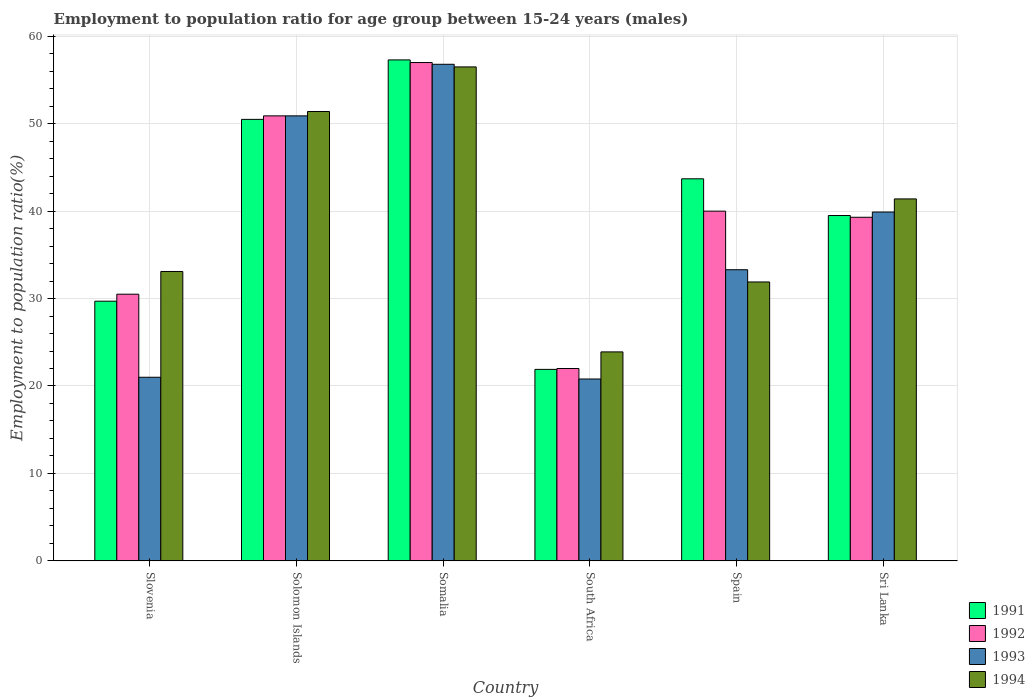How many different coloured bars are there?
Provide a short and direct response. 4. How many bars are there on the 3rd tick from the right?
Your answer should be very brief. 4. What is the employment to population ratio in 1994 in Solomon Islands?
Provide a succinct answer. 51.4. Across all countries, what is the maximum employment to population ratio in 1992?
Offer a very short reply. 57. Across all countries, what is the minimum employment to population ratio in 1993?
Give a very brief answer. 20.8. In which country was the employment to population ratio in 1991 maximum?
Ensure brevity in your answer.  Somalia. In which country was the employment to population ratio in 1991 minimum?
Offer a very short reply. South Africa. What is the total employment to population ratio in 1992 in the graph?
Provide a short and direct response. 239.7. What is the difference between the employment to population ratio in 1994 in Solomon Islands and that in Spain?
Make the answer very short. 19.5. What is the difference between the employment to population ratio in 1994 in Sri Lanka and the employment to population ratio in 1991 in Solomon Islands?
Your answer should be compact. -9.1. What is the average employment to population ratio in 1994 per country?
Make the answer very short. 39.7. What is the difference between the employment to population ratio of/in 1992 and employment to population ratio of/in 1994 in Slovenia?
Your response must be concise. -2.6. In how many countries, is the employment to population ratio in 1992 greater than 50 %?
Give a very brief answer. 2. What is the ratio of the employment to population ratio in 1993 in Solomon Islands to that in South Africa?
Your response must be concise. 2.45. Is the difference between the employment to population ratio in 1992 in Somalia and Sri Lanka greater than the difference between the employment to population ratio in 1994 in Somalia and Sri Lanka?
Provide a succinct answer. Yes. In how many countries, is the employment to population ratio in 1993 greater than the average employment to population ratio in 1993 taken over all countries?
Offer a terse response. 3. Is it the case that in every country, the sum of the employment to population ratio in 1991 and employment to population ratio in 1992 is greater than the sum of employment to population ratio in 1994 and employment to population ratio in 1993?
Ensure brevity in your answer.  No. Is it the case that in every country, the sum of the employment to population ratio in 1991 and employment to population ratio in 1992 is greater than the employment to population ratio in 1994?
Provide a short and direct response. Yes. Are the values on the major ticks of Y-axis written in scientific E-notation?
Offer a very short reply. No. What is the title of the graph?
Offer a very short reply. Employment to population ratio for age group between 15-24 years (males). What is the label or title of the Y-axis?
Keep it short and to the point. Employment to population ratio(%). What is the Employment to population ratio(%) in 1991 in Slovenia?
Your answer should be compact. 29.7. What is the Employment to population ratio(%) of 1992 in Slovenia?
Offer a very short reply. 30.5. What is the Employment to population ratio(%) of 1994 in Slovenia?
Make the answer very short. 33.1. What is the Employment to population ratio(%) in 1991 in Solomon Islands?
Give a very brief answer. 50.5. What is the Employment to population ratio(%) in 1992 in Solomon Islands?
Your response must be concise. 50.9. What is the Employment to population ratio(%) in 1993 in Solomon Islands?
Provide a succinct answer. 50.9. What is the Employment to population ratio(%) of 1994 in Solomon Islands?
Make the answer very short. 51.4. What is the Employment to population ratio(%) in 1991 in Somalia?
Provide a short and direct response. 57.3. What is the Employment to population ratio(%) of 1992 in Somalia?
Give a very brief answer. 57. What is the Employment to population ratio(%) of 1993 in Somalia?
Offer a terse response. 56.8. What is the Employment to population ratio(%) of 1994 in Somalia?
Make the answer very short. 56.5. What is the Employment to population ratio(%) in 1991 in South Africa?
Give a very brief answer. 21.9. What is the Employment to population ratio(%) in 1992 in South Africa?
Give a very brief answer. 22. What is the Employment to population ratio(%) in 1993 in South Africa?
Ensure brevity in your answer.  20.8. What is the Employment to population ratio(%) in 1994 in South Africa?
Provide a succinct answer. 23.9. What is the Employment to population ratio(%) of 1991 in Spain?
Offer a very short reply. 43.7. What is the Employment to population ratio(%) of 1992 in Spain?
Ensure brevity in your answer.  40. What is the Employment to population ratio(%) of 1993 in Spain?
Offer a terse response. 33.3. What is the Employment to population ratio(%) in 1994 in Spain?
Provide a short and direct response. 31.9. What is the Employment to population ratio(%) in 1991 in Sri Lanka?
Offer a very short reply. 39.5. What is the Employment to population ratio(%) of 1992 in Sri Lanka?
Offer a terse response. 39.3. What is the Employment to population ratio(%) in 1993 in Sri Lanka?
Ensure brevity in your answer.  39.9. What is the Employment to population ratio(%) of 1994 in Sri Lanka?
Keep it short and to the point. 41.4. Across all countries, what is the maximum Employment to population ratio(%) of 1991?
Your answer should be very brief. 57.3. Across all countries, what is the maximum Employment to population ratio(%) of 1992?
Offer a very short reply. 57. Across all countries, what is the maximum Employment to population ratio(%) of 1993?
Your response must be concise. 56.8. Across all countries, what is the maximum Employment to population ratio(%) in 1994?
Your response must be concise. 56.5. Across all countries, what is the minimum Employment to population ratio(%) of 1991?
Offer a terse response. 21.9. Across all countries, what is the minimum Employment to population ratio(%) in 1992?
Offer a terse response. 22. Across all countries, what is the minimum Employment to population ratio(%) in 1993?
Offer a terse response. 20.8. Across all countries, what is the minimum Employment to population ratio(%) in 1994?
Your answer should be very brief. 23.9. What is the total Employment to population ratio(%) of 1991 in the graph?
Keep it short and to the point. 242.6. What is the total Employment to population ratio(%) of 1992 in the graph?
Make the answer very short. 239.7. What is the total Employment to population ratio(%) in 1993 in the graph?
Offer a terse response. 222.7. What is the total Employment to population ratio(%) of 1994 in the graph?
Provide a succinct answer. 238.2. What is the difference between the Employment to population ratio(%) of 1991 in Slovenia and that in Solomon Islands?
Ensure brevity in your answer.  -20.8. What is the difference between the Employment to population ratio(%) of 1992 in Slovenia and that in Solomon Islands?
Provide a short and direct response. -20.4. What is the difference between the Employment to population ratio(%) of 1993 in Slovenia and that in Solomon Islands?
Ensure brevity in your answer.  -29.9. What is the difference between the Employment to population ratio(%) in 1994 in Slovenia and that in Solomon Islands?
Keep it short and to the point. -18.3. What is the difference between the Employment to population ratio(%) in 1991 in Slovenia and that in Somalia?
Keep it short and to the point. -27.6. What is the difference between the Employment to population ratio(%) of 1992 in Slovenia and that in Somalia?
Keep it short and to the point. -26.5. What is the difference between the Employment to population ratio(%) in 1993 in Slovenia and that in Somalia?
Offer a terse response. -35.8. What is the difference between the Employment to population ratio(%) in 1994 in Slovenia and that in Somalia?
Provide a succinct answer. -23.4. What is the difference between the Employment to population ratio(%) in 1993 in Slovenia and that in South Africa?
Your answer should be very brief. 0.2. What is the difference between the Employment to population ratio(%) of 1991 in Slovenia and that in Spain?
Make the answer very short. -14. What is the difference between the Employment to population ratio(%) of 1992 in Slovenia and that in Sri Lanka?
Make the answer very short. -8.8. What is the difference between the Employment to population ratio(%) in 1993 in Slovenia and that in Sri Lanka?
Provide a short and direct response. -18.9. What is the difference between the Employment to population ratio(%) in 1994 in Slovenia and that in Sri Lanka?
Your answer should be compact. -8.3. What is the difference between the Employment to population ratio(%) of 1991 in Solomon Islands and that in Somalia?
Your answer should be very brief. -6.8. What is the difference between the Employment to population ratio(%) in 1994 in Solomon Islands and that in Somalia?
Your response must be concise. -5.1. What is the difference between the Employment to population ratio(%) in 1991 in Solomon Islands and that in South Africa?
Keep it short and to the point. 28.6. What is the difference between the Employment to population ratio(%) in 1992 in Solomon Islands and that in South Africa?
Make the answer very short. 28.9. What is the difference between the Employment to population ratio(%) in 1993 in Solomon Islands and that in South Africa?
Make the answer very short. 30.1. What is the difference between the Employment to population ratio(%) of 1994 in Solomon Islands and that in South Africa?
Provide a succinct answer. 27.5. What is the difference between the Employment to population ratio(%) of 1992 in Solomon Islands and that in Spain?
Provide a succinct answer. 10.9. What is the difference between the Employment to population ratio(%) of 1993 in Solomon Islands and that in Spain?
Offer a very short reply. 17.6. What is the difference between the Employment to population ratio(%) in 1991 in Solomon Islands and that in Sri Lanka?
Make the answer very short. 11. What is the difference between the Employment to population ratio(%) in 1994 in Solomon Islands and that in Sri Lanka?
Ensure brevity in your answer.  10. What is the difference between the Employment to population ratio(%) in 1991 in Somalia and that in South Africa?
Offer a terse response. 35.4. What is the difference between the Employment to population ratio(%) of 1992 in Somalia and that in South Africa?
Your answer should be compact. 35. What is the difference between the Employment to population ratio(%) of 1994 in Somalia and that in South Africa?
Ensure brevity in your answer.  32.6. What is the difference between the Employment to population ratio(%) of 1994 in Somalia and that in Spain?
Your response must be concise. 24.6. What is the difference between the Employment to population ratio(%) of 1992 in Somalia and that in Sri Lanka?
Give a very brief answer. 17.7. What is the difference between the Employment to population ratio(%) of 1993 in Somalia and that in Sri Lanka?
Provide a succinct answer. 16.9. What is the difference between the Employment to population ratio(%) in 1994 in Somalia and that in Sri Lanka?
Provide a succinct answer. 15.1. What is the difference between the Employment to population ratio(%) of 1991 in South Africa and that in Spain?
Ensure brevity in your answer.  -21.8. What is the difference between the Employment to population ratio(%) in 1992 in South Africa and that in Spain?
Provide a short and direct response. -18. What is the difference between the Employment to population ratio(%) of 1993 in South Africa and that in Spain?
Keep it short and to the point. -12.5. What is the difference between the Employment to population ratio(%) of 1994 in South Africa and that in Spain?
Give a very brief answer. -8. What is the difference between the Employment to population ratio(%) in 1991 in South Africa and that in Sri Lanka?
Give a very brief answer. -17.6. What is the difference between the Employment to population ratio(%) in 1992 in South Africa and that in Sri Lanka?
Your answer should be compact. -17.3. What is the difference between the Employment to population ratio(%) of 1993 in South Africa and that in Sri Lanka?
Make the answer very short. -19.1. What is the difference between the Employment to population ratio(%) of 1994 in South Africa and that in Sri Lanka?
Your answer should be compact. -17.5. What is the difference between the Employment to population ratio(%) in 1992 in Spain and that in Sri Lanka?
Your answer should be compact. 0.7. What is the difference between the Employment to population ratio(%) in 1994 in Spain and that in Sri Lanka?
Your answer should be very brief. -9.5. What is the difference between the Employment to population ratio(%) of 1991 in Slovenia and the Employment to population ratio(%) of 1992 in Solomon Islands?
Provide a succinct answer. -21.2. What is the difference between the Employment to population ratio(%) of 1991 in Slovenia and the Employment to population ratio(%) of 1993 in Solomon Islands?
Your answer should be compact. -21.2. What is the difference between the Employment to population ratio(%) in 1991 in Slovenia and the Employment to population ratio(%) in 1994 in Solomon Islands?
Make the answer very short. -21.7. What is the difference between the Employment to population ratio(%) in 1992 in Slovenia and the Employment to population ratio(%) in 1993 in Solomon Islands?
Provide a short and direct response. -20.4. What is the difference between the Employment to population ratio(%) in 1992 in Slovenia and the Employment to population ratio(%) in 1994 in Solomon Islands?
Keep it short and to the point. -20.9. What is the difference between the Employment to population ratio(%) of 1993 in Slovenia and the Employment to population ratio(%) of 1994 in Solomon Islands?
Ensure brevity in your answer.  -30.4. What is the difference between the Employment to population ratio(%) in 1991 in Slovenia and the Employment to population ratio(%) in 1992 in Somalia?
Give a very brief answer. -27.3. What is the difference between the Employment to population ratio(%) of 1991 in Slovenia and the Employment to population ratio(%) of 1993 in Somalia?
Ensure brevity in your answer.  -27.1. What is the difference between the Employment to population ratio(%) in 1991 in Slovenia and the Employment to population ratio(%) in 1994 in Somalia?
Your answer should be compact. -26.8. What is the difference between the Employment to population ratio(%) of 1992 in Slovenia and the Employment to population ratio(%) of 1993 in Somalia?
Your answer should be compact. -26.3. What is the difference between the Employment to population ratio(%) of 1993 in Slovenia and the Employment to population ratio(%) of 1994 in Somalia?
Offer a terse response. -35.5. What is the difference between the Employment to population ratio(%) in 1991 in Slovenia and the Employment to population ratio(%) in 1992 in South Africa?
Keep it short and to the point. 7.7. What is the difference between the Employment to population ratio(%) in 1993 in Slovenia and the Employment to population ratio(%) in 1994 in South Africa?
Provide a succinct answer. -2.9. What is the difference between the Employment to population ratio(%) of 1991 in Slovenia and the Employment to population ratio(%) of 1993 in Spain?
Give a very brief answer. -3.6. What is the difference between the Employment to population ratio(%) of 1991 in Slovenia and the Employment to population ratio(%) of 1994 in Spain?
Keep it short and to the point. -2.2. What is the difference between the Employment to population ratio(%) of 1992 in Slovenia and the Employment to population ratio(%) of 1993 in Spain?
Ensure brevity in your answer.  -2.8. What is the difference between the Employment to population ratio(%) in 1992 in Slovenia and the Employment to population ratio(%) in 1994 in Spain?
Your answer should be compact. -1.4. What is the difference between the Employment to population ratio(%) of 1993 in Slovenia and the Employment to population ratio(%) of 1994 in Spain?
Provide a succinct answer. -10.9. What is the difference between the Employment to population ratio(%) of 1991 in Slovenia and the Employment to population ratio(%) of 1992 in Sri Lanka?
Offer a very short reply. -9.6. What is the difference between the Employment to population ratio(%) in 1991 in Slovenia and the Employment to population ratio(%) in 1994 in Sri Lanka?
Your answer should be compact. -11.7. What is the difference between the Employment to population ratio(%) in 1992 in Slovenia and the Employment to population ratio(%) in 1994 in Sri Lanka?
Ensure brevity in your answer.  -10.9. What is the difference between the Employment to population ratio(%) in 1993 in Slovenia and the Employment to population ratio(%) in 1994 in Sri Lanka?
Ensure brevity in your answer.  -20.4. What is the difference between the Employment to population ratio(%) of 1991 in Solomon Islands and the Employment to population ratio(%) of 1992 in Somalia?
Your answer should be very brief. -6.5. What is the difference between the Employment to population ratio(%) of 1992 in Solomon Islands and the Employment to population ratio(%) of 1993 in Somalia?
Make the answer very short. -5.9. What is the difference between the Employment to population ratio(%) of 1992 in Solomon Islands and the Employment to population ratio(%) of 1994 in Somalia?
Provide a succinct answer. -5.6. What is the difference between the Employment to population ratio(%) in 1993 in Solomon Islands and the Employment to population ratio(%) in 1994 in Somalia?
Ensure brevity in your answer.  -5.6. What is the difference between the Employment to population ratio(%) in 1991 in Solomon Islands and the Employment to population ratio(%) in 1992 in South Africa?
Offer a very short reply. 28.5. What is the difference between the Employment to population ratio(%) in 1991 in Solomon Islands and the Employment to population ratio(%) in 1993 in South Africa?
Provide a succinct answer. 29.7. What is the difference between the Employment to population ratio(%) in 1991 in Solomon Islands and the Employment to population ratio(%) in 1994 in South Africa?
Keep it short and to the point. 26.6. What is the difference between the Employment to population ratio(%) of 1992 in Solomon Islands and the Employment to population ratio(%) of 1993 in South Africa?
Provide a succinct answer. 30.1. What is the difference between the Employment to population ratio(%) in 1992 in Solomon Islands and the Employment to population ratio(%) in 1994 in South Africa?
Offer a terse response. 27. What is the difference between the Employment to population ratio(%) in 1993 in Solomon Islands and the Employment to population ratio(%) in 1994 in South Africa?
Your response must be concise. 27. What is the difference between the Employment to population ratio(%) in 1992 in Solomon Islands and the Employment to population ratio(%) in 1994 in Spain?
Provide a succinct answer. 19. What is the difference between the Employment to population ratio(%) of 1992 in Solomon Islands and the Employment to population ratio(%) of 1994 in Sri Lanka?
Provide a succinct answer. 9.5. What is the difference between the Employment to population ratio(%) in 1991 in Somalia and the Employment to population ratio(%) in 1992 in South Africa?
Your answer should be very brief. 35.3. What is the difference between the Employment to population ratio(%) of 1991 in Somalia and the Employment to population ratio(%) of 1993 in South Africa?
Provide a short and direct response. 36.5. What is the difference between the Employment to population ratio(%) in 1991 in Somalia and the Employment to population ratio(%) in 1994 in South Africa?
Offer a very short reply. 33.4. What is the difference between the Employment to population ratio(%) of 1992 in Somalia and the Employment to population ratio(%) of 1993 in South Africa?
Your answer should be very brief. 36.2. What is the difference between the Employment to population ratio(%) of 1992 in Somalia and the Employment to population ratio(%) of 1994 in South Africa?
Offer a terse response. 33.1. What is the difference between the Employment to population ratio(%) in 1993 in Somalia and the Employment to population ratio(%) in 1994 in South Africa?
Offer a terse response. 32.9. What is the difference between the Employment to population ratio(%) in 1991 in Somalia and the Employment to population ratio(%) in 1992 in Spain?
Keep it short and to the point. 17.3. What is the difference between the Employment to population ratio(%) in 1991 in Somalia and the Employment to population ratio(%) in 1993 in Spain?
Offer a terse response. 24. What is the difference between the Employment to population ratio(%) in 1991 in Somalia and the Employment to population ratio(%) in 1994 in Spain?
Give a very brief answer. 25.4. What is the difference between the Employment to population ratio(%) in 1992 in Somalia and the Employment to population ratio(%) in 1993 in Spain?
Keep it short and to the point. 23.7. What is the difference between the Employment to population ratio(%) of 1992 in Somalia and the Employment to population ratio(%) of 1994 in Spain?
Your answer should be compact. 25.1. What is the difference between the Employment to population ratio(%) in 1993 in Somalia and the Employment to population ratio(%) in 1994 in Spain?
Your response must be concise. 24.9. What is the difference between the Employment to population ratio(%) in 1991 in Somalia and the Employment to population ratio(%) in 1992 in Sri Lanka?
Provide a succinct answer. 18. What is the difference between the Employment to population ratio(%) in 1991 in Somalia and the Employment to population ratio(%) in 1994 in Sri Lanka?
Keep it short and to the point. 15.9. What is the difference between the Employment to population ratio(%) in 1992 in Somalia and the Employment to population ratio(%) in 1993 in Sri Lanka?
Your answer should be compact. 17.1. What is the difference between the Employment to population ratio(%) in 1993 in Somalia and the Employment to population ratio(%) in 1994 in Sri Lanka?
Provide a short and direct response. 15.4. What is the difference between the Employment to population ratio(%) in 1991 in South Africa and the Employment to population ratio(%) in 1992 in Spain?
Your response must be concise. -18.1. What is the difference between the Employment to population ratio(%) of 1991 in South Africa and the Employment to population ratio(%) of 1993 in Spain?
Give a very brief answer. -11.4. What is the difference between the Employment to population ratio(%) of 1991 in South Africa and the Employment to population ratio(%) of 1994 in Spain?
Make the answer very short. -10. What is the difference between the Employment to population ratio(%) in 1992 in South Africa and the Employment to population ratio(%) in 1994 in Spain?
Offer a very short reply. -9.9. What is the difference between the Employment to population ratio(%) of 1993 in South Africa and the Employment to population ratio(%) of 1994 in Spain?
Make the answer very short. -11.1. What is the difference between the Employment to population ratio(%) in 1991 in South Africa and the Employment to population ratio(%) in 1992 in Sri Lanka?
Your answer should be compact. -17.4. What is the difference between the Employment to population ratio(%) of 1991 in South Africa and the Employment to population ratio(%) of 1993 in Sri Lanka?
Offer a very short reply. -18. What is the difference between the Employment to population ratio(%) in 1991 in South Africa and the Employment to population ratio(%) in 1994 in Sri Lanka?
Your response must be concise. -19.5. What is the difference between the Employment to population ratio(%) in 1992 in South Africa and the Employment to population ratio(%) in 1993 in Sri Lanka?
Offer a terse response. -17.9. What is the difference between the Employment to population ratio(%) in 1992 in South Africa and the Employment to population ratio(%) in 1994 in Sri Lanka?
Provide a short and direct response. -19.4. What is the difference between the Employment to population ratio(%) of 1993 in South Africa and the Employment to population ratio(%) of 1994 in Sri Lanka?
Your answer should be very brief. -20.6. What is the average Employment to population ratio(%) in 1991 per country?
Keep it short and to the point. 40.43. What is the average Employment to population ratio(%) of 1992 per country?
Your answer should be compact. 39.95. What is the average Employment to population ratio(%) in 1993 per country?
Your response must be concise. 37.12. What is the average Employment to population ratio(%) in 1994 per country?
Make the answer very short. 39.7. What is the difference between the Employment to population ratio(%) of 1991 and Employment to population ratio(%) of 1992 in Slovenia?
Provide a succinct answer. -0.8. What is the difference between the Employment to population ratio(%) of 1991 and Employment to population ratio(%) of 1993 in Slovenia?
Your answer should be compact. 8.7. What is the difference between the Employment to population ratio(%) of 1993 and Employment to population ratio(%) of 1994 in Slovenia?
Provide a succinct answer. -12.1. What is the difference between the Employment to population ratio(%) in 1991 and Employment to population ratio(%) in 1992 in Solomon Islands?
Make the answer very short. -0.4. What is the difference between the Employment to population ratio(%) in 1991 and Employment to population ratio(%) in 1994 in Solomon Islands?
Your response must be concise. -0.9. What is the difference between the Employment to population ratio(%) of 1992 and Employment to population ratio(%) of 1993 in Solomon Islands?
Provide a succinct answer. 0. What is the difference between the Employment to population ratio(%) in 1991 and Employment to population ratio(%) in 1994 in Somalia?
Provide a short and direct response. 0.8. What is the difference between the Employment to population ratio(%) in 1992 and Employment to population ratio(%) in 1994 in Somalia?
Offer a terse response. 0.5. What is the difference between the Employment to population ratio(%) in 1993 and Employment to population ratio(%) in 1994 in Somalia?
Offer a very short reply. 0.3. What is the difference between the Employment to population ratio(%) in 1991 and Employment to population ratio(%) in 1993 in South Africa?
Provide a short and direct response. 1.1. What is the difference between the Employment to population ratio(%) in 1992 and Employment to population ratio(%) in 1993 in South Africa?
Offer a very short reply. 1.2. What is the difference between the Employment to population ratio(%) of 1992 and Employment to population ratio(%) of 1994 in South Africa?
Offer a very short reply. -1.9. What is the difference between the Employment to population ratio(%) in 1993 and Employment to population ratio(%) in 1994 in South Africa?
Offer a very short reply. -3.1. What is the difference between the Employment to population ratio(%) of 1991 and Employment to population ratio(%) of 1993 in Spain?
Your answer should be very brief. 10.4. What is the difference between the Employment to population ratio(%) in 1991 and Employment to population ratio(%) in 1994 in Spain?
Make the answer very short. 11.8. What is the difference between the Employment to population ratio(%) of 1992 and Employment to population ratio(%) of 1993 in Spain?
Offer a terse response. 6.7. What is the difference between the Employment to population ratio(%) of 1992 and Employment to population ratio(%) of 1994 in Spain?
Your answer should be compact. 8.1. What is the difference between the Employment to population ratio(%) in 1991 and Employment to population ratio(%) in 1992 in Sri Lanka?
Provide a succinct answer. 0.2. What is the difference between the Employment to population ratio(%) of 1991 and Employment to population ratio(%) of 1993 in Sri Lanka?
Keep it short and to the point. -0.4. What is the difference between the Employment to population ratio(%) in 1991 and Employment to population ratio(%) in 1994 in Sri Lanka?
Offer a terse response. -1.9. What is the difference between the Employment to population ratio(%) in 1992 and Employment to population ratio(%) in 1994 in Sri Lanka?
Provide a short and direct response. -2.1. What is the difference between the Employment to population ratio(%) of 1993 and Employment to population ratio(%) of 1994 in Sri Lanka?
Offer a very short reply. -1.5. What is the ratio of the Employment to population ratio(%) in 1991 in Slovenia to that in Solomon Islands?
Keep it short and to the point. 0.59. What is the ratio of the Employment to population ratio(%) of 1992 in Slovenia to that in Solomon Islands?
Provide a succinct answer. 0.6. What is the ratio of the Employment to population ratio(%) in 1993 in Slovenia to that in Solomon Islands?
Provide a short and direct response. 0.41. What is the ratio of the Employment to population ratio(%) in 1994 in Slovenia to that in Solomon Islands?
Offer a very short reply. 0.64. What is the ratio of the Employment to population ratio(%) of 1991 in Slovenia to that in Somalia?
Make the answer very short. 0.52. What is the ratio of the Employment to population ratio(%) of 1992 in Slovenia to that in Somalia?
Keep it short and to the point. 0.54. What is the ratio of the Employment to population ratio(%) of 1993 in Slovenia to that in Somalia?
Ensure brevity in your answer.  0.37. What is the ratio of the Employment to population ratio(%) in 1994 in Slovenia to that in Somalia?
Your answer should be very brief. 0.59. What is the ratio of the Employment to population ratio(%) in 1991 in Slovenia to that in South Africa?
Offer a very short reply. 1.36. What is the ratio of the Employment to population ratio(%) in 1992 in Slovenia to that in South Africa?
Offer a very short reply. 1.39. What is the ratio of the Employment to population ratio(%) in 1993 in Slovenia to that in South Africa?
Offer a terse response. 1.01. What is the ratio of the Employment to population ratio(%) in 1994 in Slovenia to that in South Africa?
Give a very brief answer. 1.38. What is the ratio of the Employment to population ratio(%) of 1991 in Slovenia to that in Spain?
Your answer should be compact. 0.68. What is the ratio of the Employment to population ratio(%) in 1992 in Slovenia to that in Spain?
Ensure brevity in your answer.  0.76. What is the ratio of the Employment to population ratio(%) in 1993 in Slovenia to that in Spain?
Your answer should be very brief. 0.63. What is the ratio of the Employment to population ratio(%) of 1994 in Slovenia to that in Spain?
Provide a short and direct response. 1.04. What is the ratio of the Employment to population ratio(%) in 1991 in Slovenia to that in Sri Lanka?
Offer a terse response. 0.75. What is the ratio of the Employment to population ratio(%) in 1992 in Slovenia to that in Sri Lanka?
Provide a succinct answer. 0.78. What is the ratio of the Employment to population ratio(%) of 1993 in Slovenia to that in Sri Lanka?
Offer a very short reply. 0.53. What is the ratio of the Employment to population ratio(%) in 1994 in Slovenia to that in Sri Lanka?
Provide a succinct answer. 0.8. What is the ratio of the Employment to population ratio(%) of 1991 in Solomon Islands to that in Somalia?
Give a very brief answer. 0.88. What is the ratio of the Employment to population ratio(%) of 1992 in Solomon Islands to that in Somalia?
Your answer should be compact. 0.89. What is the ratio of the Employment to population ratio(%) of 1993 in Solomon Islands to that in Somalia?
Your answer should be very brief. 0.9. What is the ratio of the Employment to population ratio(%) in 1994 in Solomon Islands to that in Somalia?
Your answer should be very brief. 0.91. What is the ratio of the Employment to population ratio(%) of 1991 in Solomon Islands to that in South Africa?
Offer a very short reply. 2.31. What is the ratio of the Employment to population ratio(%) in 1992 in Solomon Islands to that in South Africa?
Offer a very short reply. 2.31. What is the ratio of the Employment to population ratio(%) of 1993 in Solomon Islands to that in South Africa?
Your response must be concise. 2.45. What is the ratio of the Employment to population ratio(%) in 1994 in Solomon Islands to that in South Africa?
Your response must be concise. 2.15. What is the ratio of the Employment to population ratio(%) in 1991 in Solomon Islands to that in Spain?
Offer a terse response. 1.16. What is the ratio of the Employment to population ratio(%) of 1992 in Solomon Islands to that in Spain?
Give a very brief answer. 1.27. What is the ratio of the Employment to population ratio(%) in 1993 in Solomon Islands to that in Spain?
Keep it short and to the point. 1.53. What is the ratio of the Employment to population ratio(%) in 1994 in Solomon Islands to that in Spain?
Offer a terse response. 1.61. What is the ratio of the Employment to population ratio(%) of 1991 in Solomon Islands to that in Sri Lanka?
Your response must be concise. 1.28. What is the ratio of the Employment to population ratio(%) in 1992 in Solomon Islands to that in Sri Lanka?
Ensure brevity in your answer.  1.3. What is the ratio of the Employment to population ratio(%) of 1993 in Solomon Islands to that in Sri Lanka?
Your answer should be compact. 1.28. What is the ratio of the Employment to population ratio(%) in 1994 in Solomon Islands to that in Sri Lanka?
Keep it short and to the point. 1.24. What is the ratio of the Employment to population ratio(%) of 1991 in Somalia to that in South Africa?
Provide a succinct answer. 2.62. What is the ratio of the Employment to population ratio(%) in 1992 in Somalia to that in South Africa?
Keep it short and to the point. 2.59. What is the ratio of the Employment to population ratio(%) of 1993 in Somalia to that in South Africa?
Offer a very short reply. 2.73. What is the ratio of the Employment to population ratio(%) in 1994 in Somalia to that in South Africa?
Ensure brevity in your answer.  2.36. What is the ratio of the Employment to population ratio(%) of 1991 in Somalia to that in Spain?
Give a very brief answer. 1.31. What is the ratio of the Employment to population ratio(%) of 1992 in Somalia to that in Spain?
Your response must be concise. 1.43. What is the ratio of the Employment to population ratio(%) in 1993 in Somalia to that in Spain?
Keep it short and to the point. 1.71. What is the ratio of the Employment to population ratio(%) in 1994 in Somalia to that in Spain?
Give a very brief answer. 1.77. What is the ratio of the Employment to population ratio(%) of 1991 in Somalia to that in Sri Lanka?
Offer a very short reply. 1.45. What is the ratio of the Employment to population ratio(%) in 1992 in Somalia to that in Sri Lanka?
Ensure brevity in your answer.  1.45. What is the ratio of the Employment to population ratio(%) in 1993 in Somalia to that in Sri Lanka?
Your response must be concise. 1.42. What is the ratio of the Employment to population ratio(%) of 1994 in Somalia to that in Sri Lanka?
Your answer should be compact. 1.36. What is the ratio of the Employment to population ratio(%) of 1991 in South Africa to that in Spain?
Offer a very short reply. 0.5. What is the ratio of the Employment to population ratio(%) in 1992 in South Africa to that in Spain?
Make the answer very short. 0.55. What is the ratio of the Employment to population ratio(%) of 1993 in South Africa to that in Spain?
Provide a short and direct response. 0.62. What is the ratio of the Employment to population ratio(%) of 1994 in South Africa to that in Spain?
Ensure brevity in your answer.  0.75. What is the ratio of the Employment to population ratio(%) in 1991 in South Africa to that in Sri Lanka?
Keep it short and to the point. 0.55. What is the ratio of the Employment to population ratio(%) of 1992 in South Africa to that in Sri Lanka?
Your response must be concise. 0.56. What is the ratio of the Employment to population ratio(%) of 1993 in South Africa to that in Sri Lanka?
Make the answer very short. 0.52. What is the ratio of the Employment to population ratio(%) in 1994 in South Africa to that in Sri Lanka?
Provide a succinct answer. 0.58. What is the ratio of the Employment to population ratio(%) in 1991 in Spain to that in Sri Lanka?
Your response must be concise. 1.11. What is the ratio of the Employment to population ratio(%) of 1992 in Spain to that in Sri Lanka?
Ensure brevity in your answer.  1.02. What is the ratio of the Employment to population ratio(%) of 1993 in Spain to that in Sri Lanka?
Your answer should be very brief. 0.83. What is the ratio of the Employment to population ratio(%) of 1994 in Spain to that in Sri Lanka?
Offer a terse response. 0.77. What is the difference between the highest and the second highest Employment to population ratio(%) of 1992?
Your answer should be compact. 6.1. What is the difference between the highest and the second highest Employment to population ratio(%) in 1994?
Offer a terse response. 5.1. What is the difference between the highest and the lowest Employment to population ratio(%) of 1991?
Give a very brief answer. 35.4. What is the difference between the highest and the lowest Employment to population ratio(%) of 1992?
Provide a short and direct response. 35. What is the difference between the highest and the lowest Employment to population ratio(%) of 1994?
Provide a short and direct response. 32.6. 